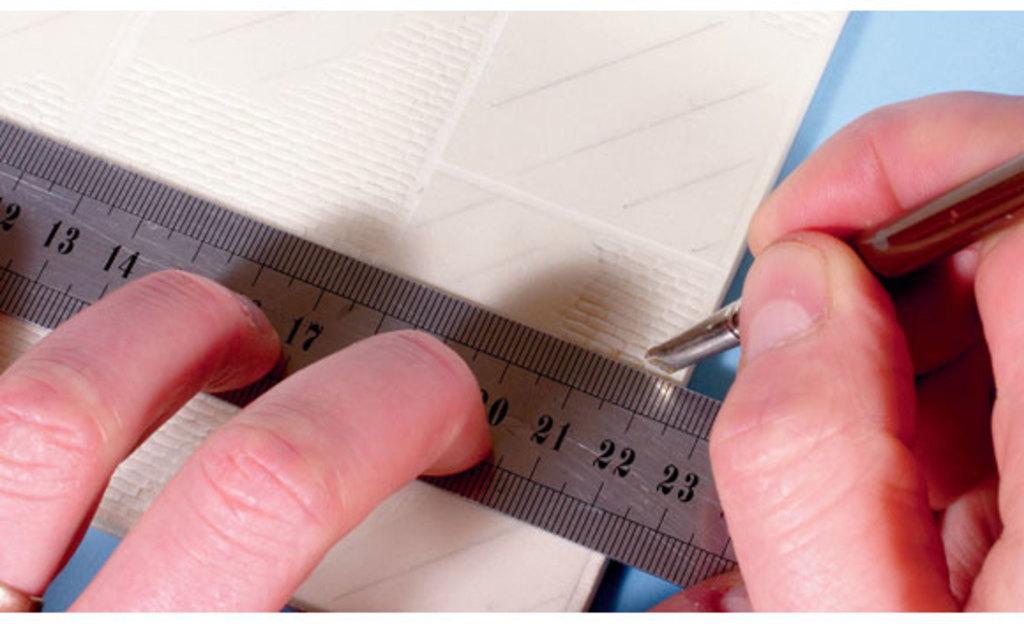Top which number is the pen closest to?
Make the answer very short. 22. What number is between the two left fingers?
Make the answer very short. 17. 